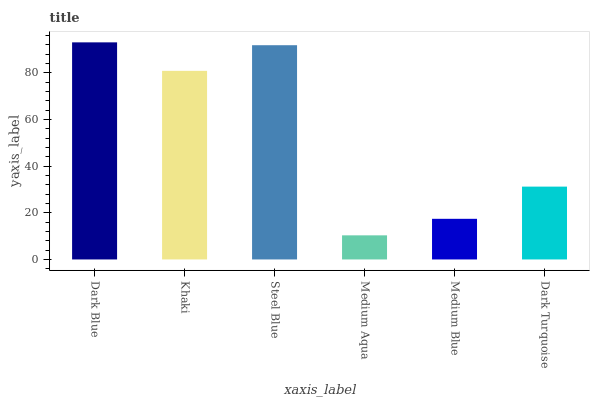Is Medium Aqua the minimum?
Answer yes or no. Yes. Is Dark Blue the maximum?
Answer yes or no. Yes. Is Khaki the minimum?
Answer yes or no. No. Is Khaki the maximum?
Answer yes or no. No. Is Dark Blue greater than Khaki?
Answer yes or no. Yes. Is Khaki less than Dark Blue?
Answer yes or no. Yes. Is Khaki greater than Dark Blue?
Answer yes or no. No. Is Dark Blue less than Khaki?
Answer yes or no. No. Is Khaki the high median?
Answer yes or no. Yes. Is Dark Turquoise the low median?
Answer yes or no. Yes. Is Dark Turquoise the high median?
Answer yes or no. No. Is Medium Blue the low median?
Answer yes or no. No. 